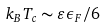Convert formula to latex. <formula><loc_0><loc_0><loc_500><loc_500>k _ { B } T _ { c } \sim \varepsilon \epsilon _ { F } / 6</formula> 